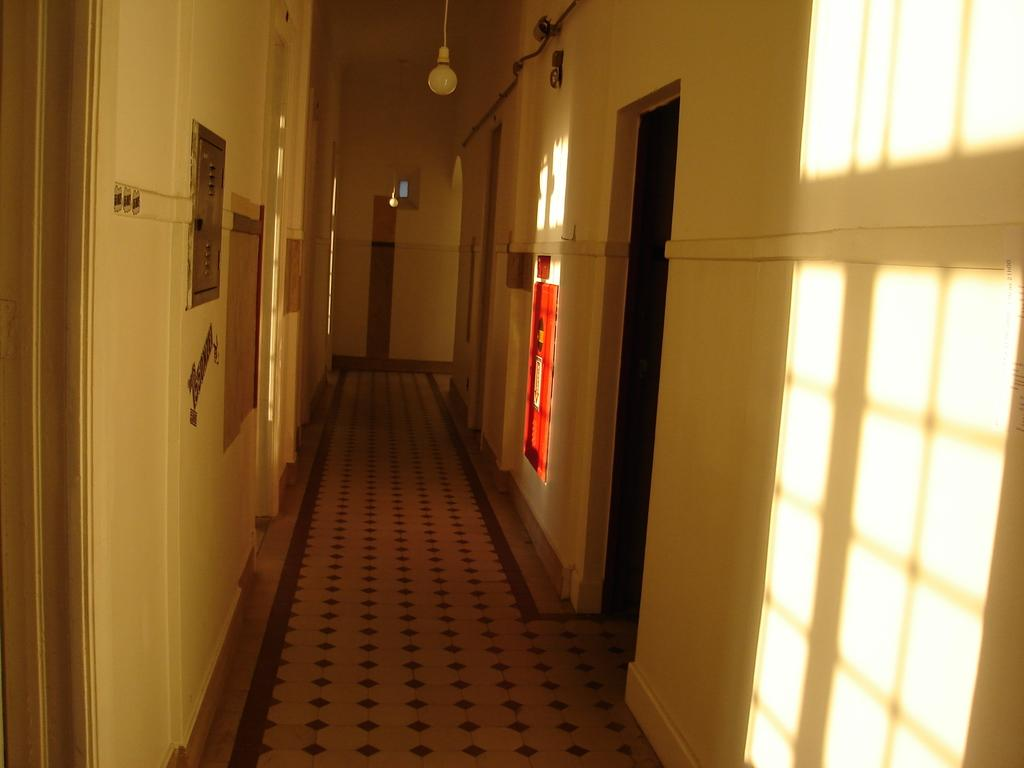What is hanging from the roof in the image? There are lights hanging from the roof in the image. What else can be seen in the image besides the lights? There are wires visible in the image, as well as doors and a CCTV camera. What might be the purpose of the CCTV camera in the image? The CCTV camera in the image might be used for security or surveillance purposes. What is the source of the shadow visible in the image? The shadow of windows is visible in the image. Can you see any mittens being used by a servant in the image? There are no mittens or servants present in the image. Is there a river flowing through the area depicted in the image? There is no river visible in the image. 